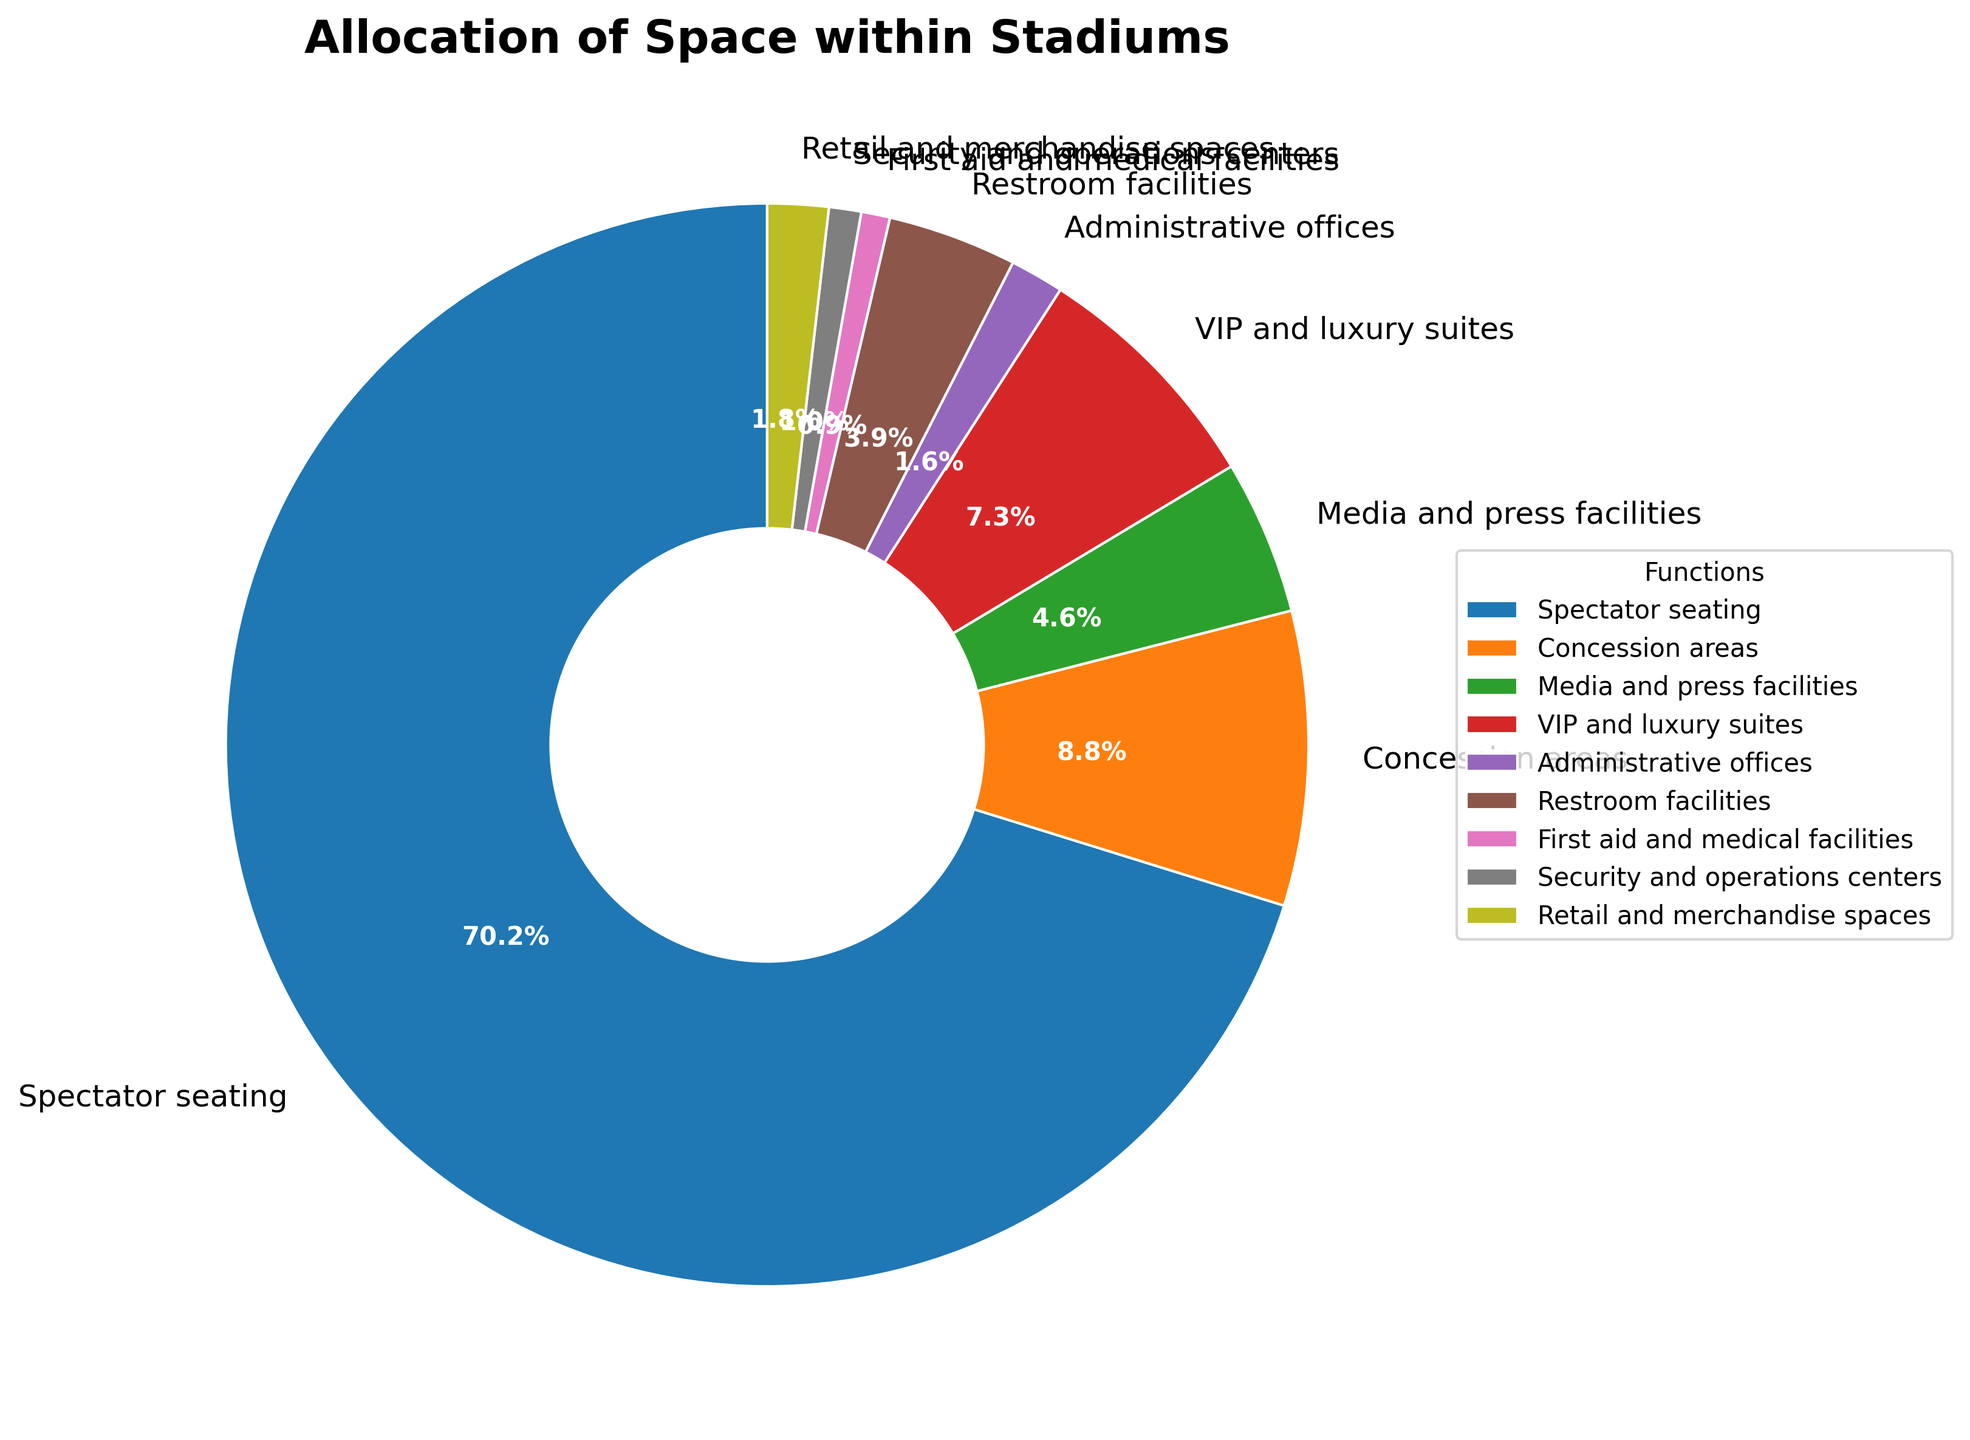What percentage of the stadium space is allocated to Spectator seating and VIP and luxury suites combined? To find the combined percentage for Spectator seating and VIP and luxury suites, add their individual percentages: 65.5% + 6.8% = 72.3%
Answer: 72.3% Which function takes up more space: Concession areas or Media and press facilities? Compare the percentages of Concession areas (8.2%) and Media and press facilities (4.3%). Since 8.2% is greater than 4.3%, Concession areas take up more space.
Answer: Concession areas What is the difference in space allocation between Restroom facilities and Administrative offices? Subtract the percentage of Administrative offices from Restroom facilities: 3.6% - 1.5% = 2.1%
Answer: 2.1% Identify the function with the lowest percentage of space allocation. The function with the smallest percentage is First aid and medical facilities at 0.8%.
Answer: First aid and medical facilities What is the total percentage of space allocated for Media and press facilities, First aid and medical facilities, and Security and operations centers combined? Sum the percentages for Media and press facilities (4.3%), First aid and medical facilities (0.8%), and Security and operations centers (0.9%): 4.3% + 0.8% + 0.9% = 6.0%
Answer: 6.0% Is there more space dedicated to Retail and merchandise spaces than to Administrative offices? Compare the percentages of Retail and merchandise spaces (1.7%) and Administrative offices (1.5%). Since 1.7% is greater than 1.5%, more space is dedicated to Retail and merchandise spaces.
Answer: Yes Which color represents the Security and operations centers segment in the pie chart? The segment for Security and operations centers is represented by the color gray.
Answer: Gray How much more space is allocated for Spectator seating compared to Concession areas? Subtract the percentage of Concession areas from Spectator seating: 65.5% - 8.2% = 57.3%
Answer: 57.3% Are Restroom facilities given more space than Retail and merchandise spaces? Compare the percentages of Restroom facilities (3.6%) and Retail and merchandise spaces (1.7%). Since 3.6% is greater than 1.7%, Restroom facilities are given more space.
Answer: Yes 